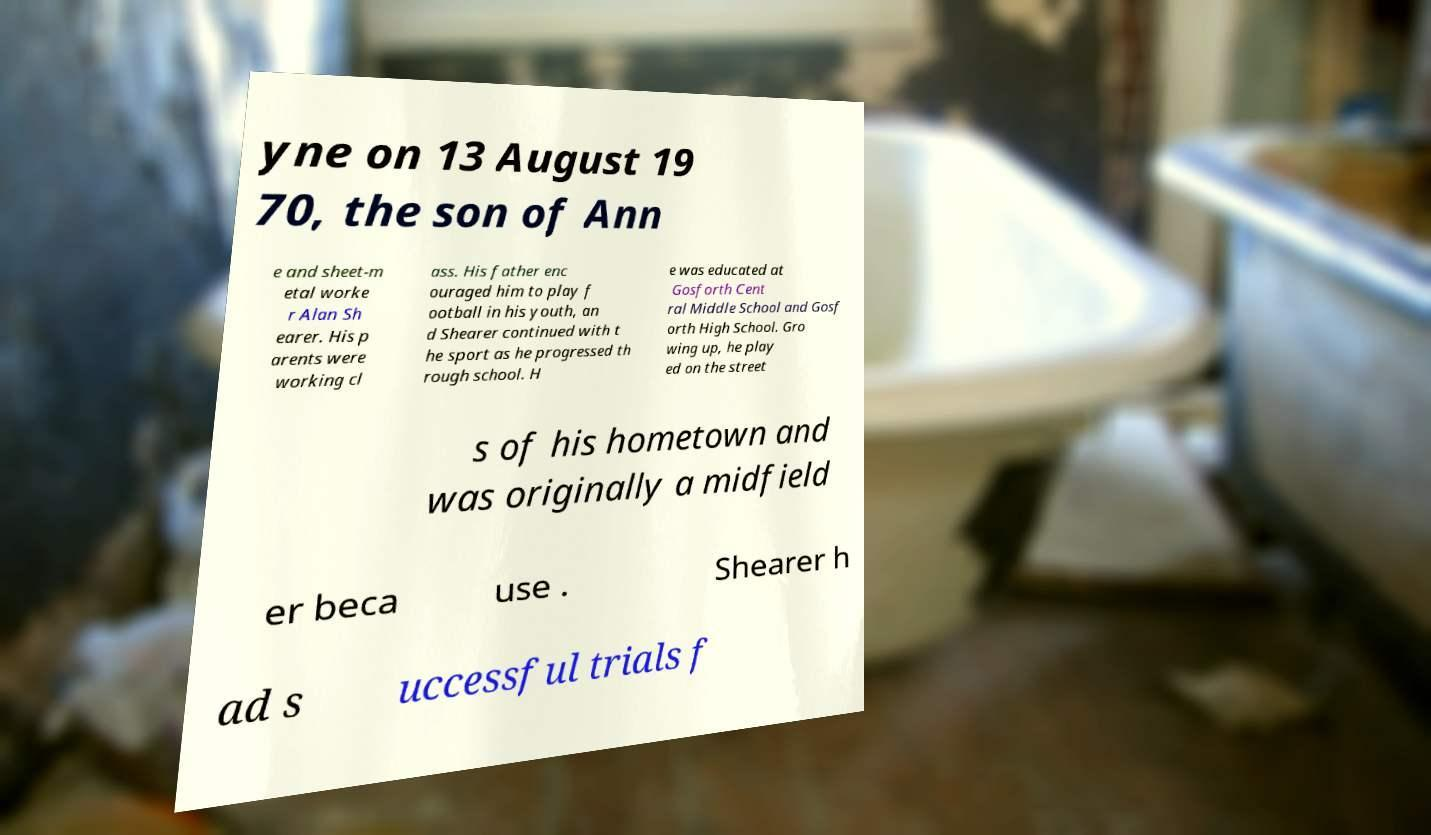Can you accurately transcribe the text from the provided image for me? yne on 13 August 19 70, the son of Ann e and sheet-m etal worke r Alan Sh earer. His p arents were working cl ass. His father enc ouraged him to play f ootball in his youth, an d Shearer continued with t he sport as he progressed th rough school. H e was educated at Gosforth Cent ral Middle School and Gosf orth High School. Gro wing up, he play ed on the street s of his hometown and was originally a midfield er beca use . Shearer h ad s uccessful trials f 